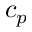Convert formula to latex. <formula><loc_0><loc_0><loc_500><loc_500>c _ { p }</formula> 